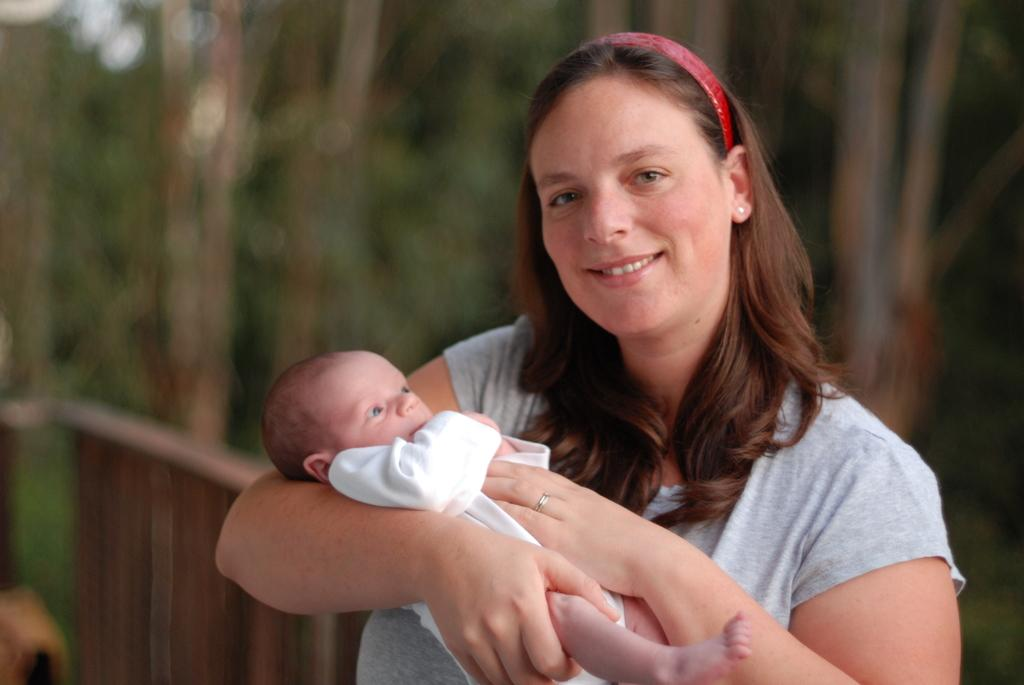Who is the main subject in the image? There is a woman in the image. What is the woman doing in the image? The woman is holding a baby. What can be seen in the background of the image? There are trees visible in the background of the image. What type of barrier is present in the image? There is a metal fence in the image. Where is the hospital located in the image? There is no hospital present in the image. Can you tell me how many quarters are visible in the image? There are no quarters visible in the image. 